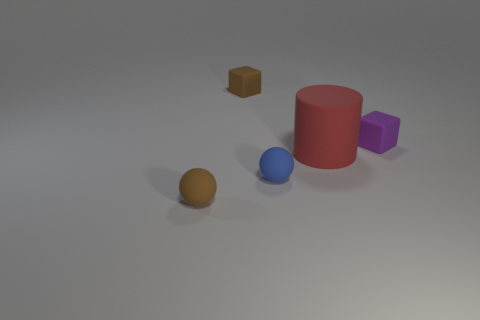There is a block that is right of the large red cylinder; what is it made of? rubber 